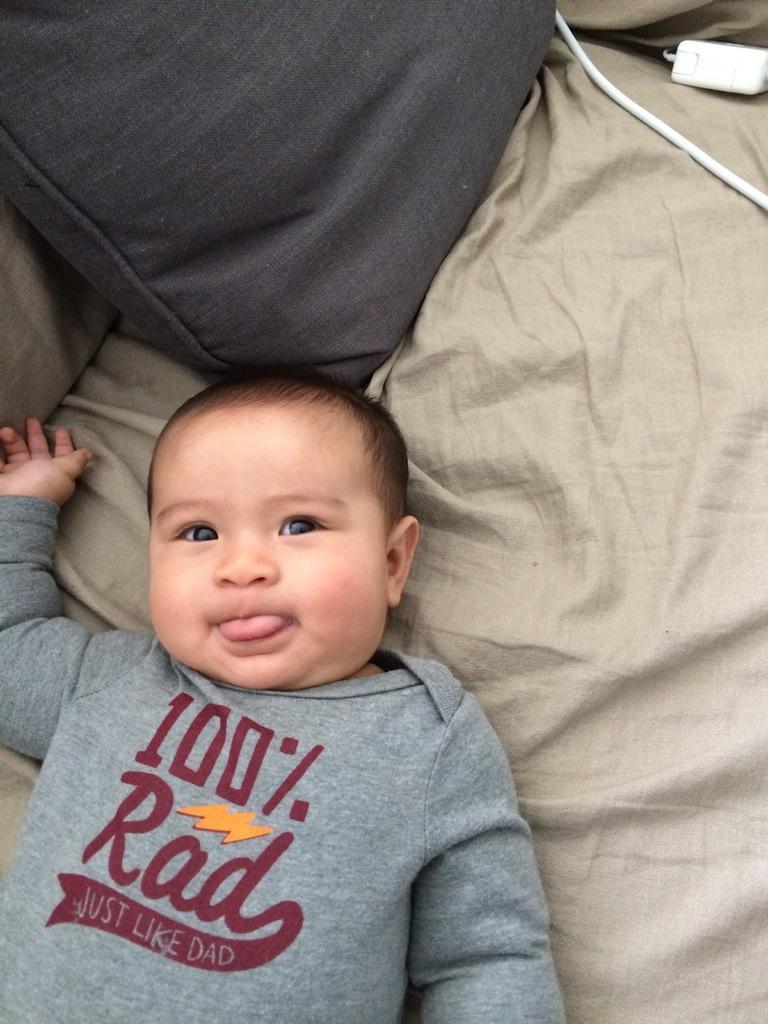How would you summarize this image in a sentence or two? In the picture I can see a baby on the bed and there is a pillow on the bed at the top of the picture. 